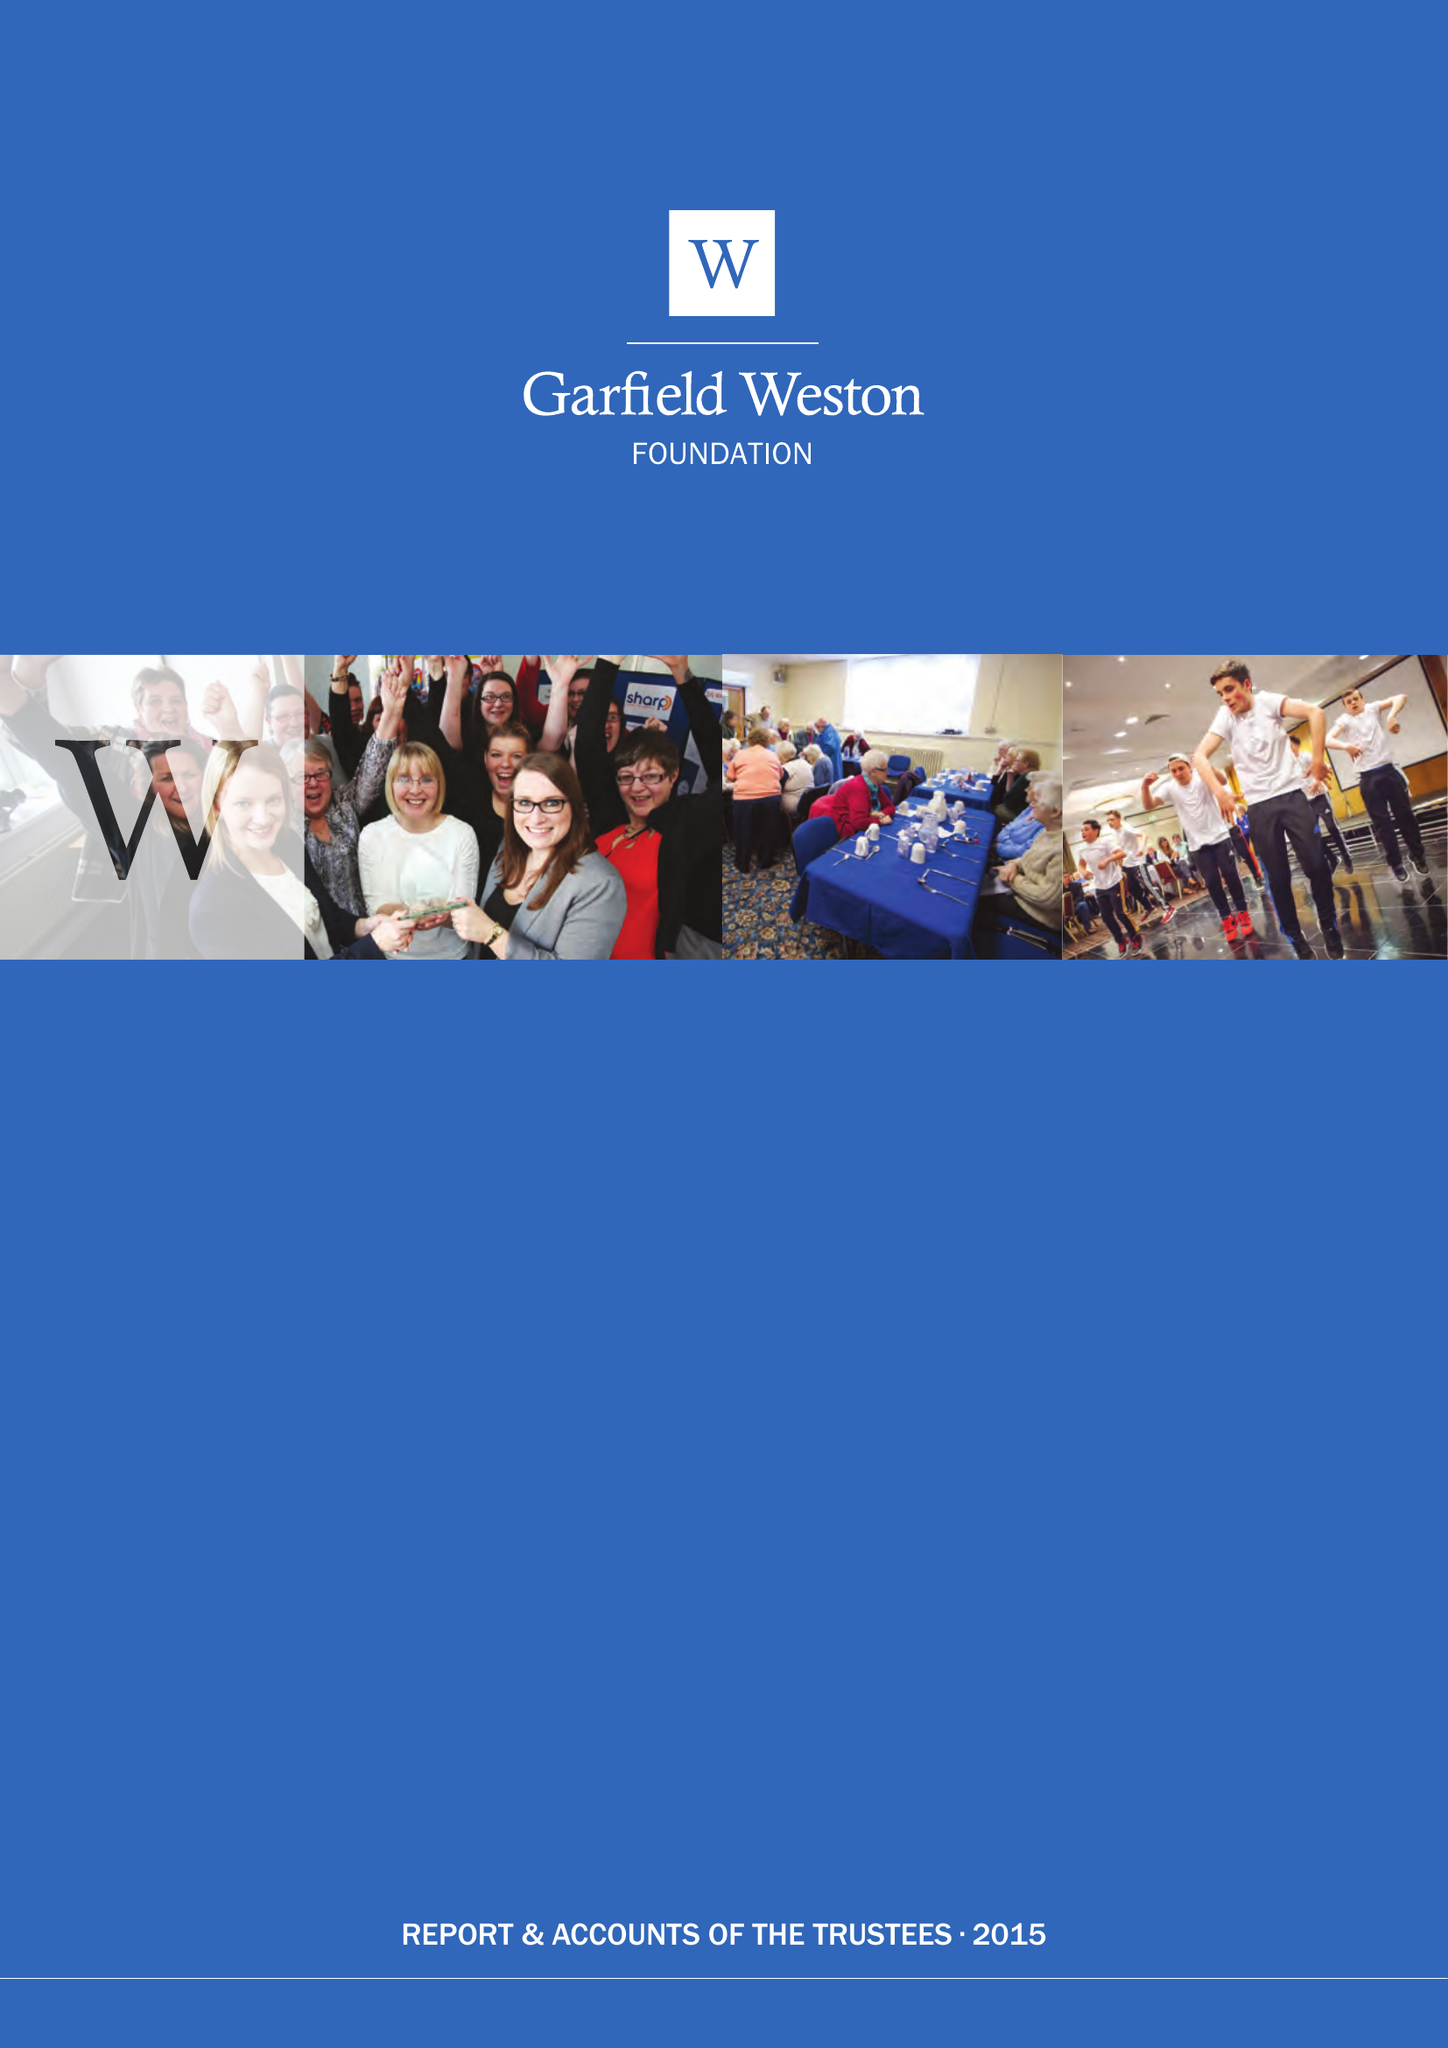What is the value for the address__postcode?
Answer the question using a single word or phrase. W1K 4QY 